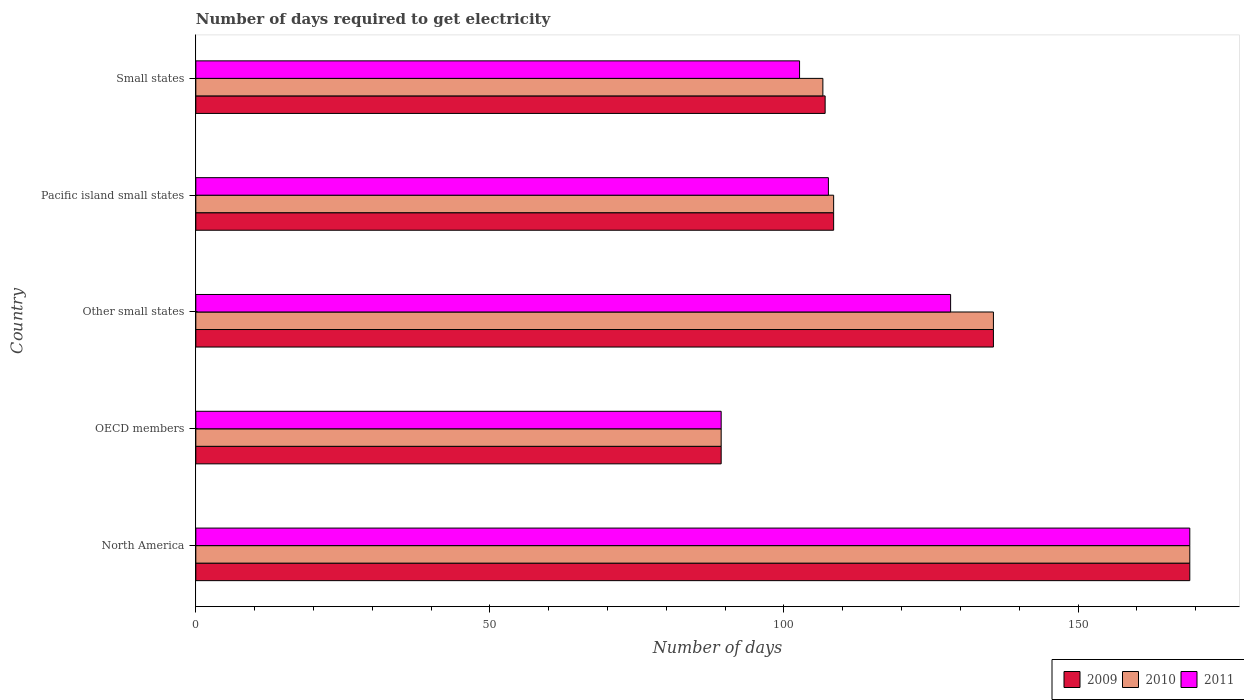How many groups of bars are there?
Your response must be concise. 5. Are the number of bars on each tick of the Y-axis equal?
Your response must be concise. Yes. How many bars are there on the 2nd tick from the bottom?
Your response must be concise. 3. What is the number of days required to get electricity in in 2011 in Small states?
Your answer should be very brief. 102.65. Across all countries, what is the maximum number of days required to get electricity in in 2011?
Offer a terse response. 169. Across all countries, what is the minimum number of days required to get electricity in in 2011?
Keep it short and to the point. 89.32. In which country was the number of days required to get electricity in in 2009 maximum?
Keep it short and to the point. North America. What is the total number of days required to get electricity in in 2011 in the graph?
Give a very brief answer. 596.86. What is the difference between the number of days required to get electricity in in 2011 in North America and that in Pacific island small states?
Offer a terse response. 61.44. What is the difference between the number of days required to get electricity in in 2011 in Other small states and the number of days required to get electricity in in 2010 in OECD members?
Provide a short and direct response. 39.01. What is the average number of days required to get electricity in in 2009 per country?
Ensure brevity in your answer.  121.88. What is the difference between the number of days required to get electricity in in 2010 and number of days required to get electricity in in 2009 in North America?
Offer a terse response. 0. In how many countries, is the number of days required to get electricity in in 2011 greater than 30 days?
Ensure brevity in your answer.  5. What is the ratio of the number of days required to get electricity in in 2011 in North America to that in Small states?
Offer a terse response. 1.65. Is the number of days required to get electricity in in 2010 in OECD members less than that in Small states?
Your answer should be compact. Yes. Is the difference between the number of days required to get electricity in in 2010 in North America and Pacific island small states greater than the difference between the number of days required to get electricity in in 2009 in North America and Pacific island small states?
Your answer should be very brief. No. What is the difference between the highest and the second highest number of days required to get electricity in in 2011?
Your answer should be compact. 40.67. What is the difference between the highest and the lowest number of days required to get electricity in in 2009?
Provide a short and direct response. 79.68. What does the 3rd bar from the top in North America represents?
Your answer should be very brief. 2009. Is it the case that in every country, the sum of the number of days required to get electricity in in 2010 and number of days required to get electricity in in 2009 is greater than the number of days required to get electricity in in 2011?
Your answer should be compact. Yes. How many bars are there?
Ensure brevity in your answer.  15. Does the graph contain grids?
Offer a very short reply. No. How are the legend labels stacked?
Offer a terse response. Horizontal. What is the title of the graph?
Give a very brief answer. Number of days required to get electricity. Does "2003" appear as one of the legend labels in the graph?
Provide a succinct answer. No. What is the label or title of the X-axis?
Offer a terse response. Number of days. What is the Number of days of 2009 in North America?
Provide a succinct answer. 169. What is the Number of days of 2010 in North America?
Provide a short and direct response. 169. What is the Number of days in 2011 in North America?
Keep it short and to the point. 169. What is the Number of days of 2009 in OECD members?
Provide a short and direct response. 89.32. What is the Number of days in 2010 in OECD members?
Your response must be concise. 89.32. What is the Number of days in 2011 in OECD members?
Your response must be concise. 89.32. What is the Number of days in 2009 in Other small states?
Offer a terse response. 135.61. What is the Number of days of 2010 in Other small states?
Your answer should be very brief. 135.61. What is the Number of days of 2011 in Other small states?
Ensure brevity in your answer.  128.33. What is the Number of days in 2009 in Pacific island small states?
Offer a terse response. 108.44. What is the Number of days of 2010 in Pacific island small states?
Give a very brief answer. 108.44. What is the Number of days in 2011 in Pacific island small states?
Your answer should be compact. 107.56. What is the Number of days of 2009 in Small states?
Offer a terse response. 107. What is the Number of days in 2010 in Small states?
Your answer should be compact. 106.62. What is the Number of days of 2011 in Small states?
Make the answer very short. 102.65. Across all countries, what is the maximum Number of days of 2009?
Your answer should be compact. 169. Across all countries, what is the maximum Number of days in 2010?
Provide a succinct answer. 169. Across all countries, what is the maximum Number of days of 2011?
Provide a short and direct response. 169. Across all countries, what is the minimum Number of days in 2009?
Your answer should be very brief. 89.32. Across all countries, what is the minimum Number of days in 2010?
Ensure brevity in your answer.  89.32. Across all countries, what is the minimum Number of days in 2011?
Offer a very short reply. 89.32. What is the total Number of days in 2009 in the graph?
Make the answer very short. 609.38. What is the total Number of days in 2010 in the graph?
Ensure brevity in your answer.  608.99. What is the total Number of days in 2011 in the graph?
Offer a very short reply. 596.86. What is the difference between the Number of days in 2009 in North America and that in OECD members?
Provide a succinct answer. 79.68. What is the difference between the Number of days of 2010 in North America and that in OECD members?
Provide a short and direct response. 79.68. What is the difference between the Number of days of 2011 in North America and that in OECD members?
Your response must be concise. 79.68. What is the difference between the Number of days in 2009 in North America and that in Other small states?
Give a very brief answer. 33.39. What is the difference between the Number of days of 2010 in North America and that in Other small states?
Ensure brevity in your answer.  33.39. What is the difference between the Number of days of 2011 in North America and that in Other small states?
Ensure brevity in your answer.  40.67. What is the difference between the Number of days of 2009 in North America and that in Pacific island small states?
Your answer should be very brief. 60.56. What is the difference between the Number of days in 2010 in North America and that in Pacific island small states?
Provide a short and direct response. 60.56. What is the difference between the Number of days of 2011 in North America and that in Pacific island small states?
Your answer should be compact. 61.44. What is the difference between the Number of days in 2009 in North America and that in Small states?
Your answer should be very brief. 62. What is the difference between the Number of days of 2010 in North America and that in Small states?
Provide a short and direct response. 62.38. What is the difference between the Number of days in 2011 in North America and that in Small states?
Provide a short and direct response. 66.35. What is the difference between the Number of days in 2009 in OECD members and that in Other small states?
Offer a very short reply. -46.29. What is the difference between the Number of days of 2010 in OECD members and that in Other small states?
Your answer should be compact. -46.29. What is the difference between the Number of days in 2011 in OECD members and that in Other small states?
Your answer should be very brief. -39.01. What is the difference between the Number of days of 2009 in OECD members and that in Pacific island small states?
Your answer should be compact. -19.12. What is the difference between the Number of days of 2010 in OECD members and that in Pacific island small states?
Make the answer very short. -19.12. What is the difference between the Number of days in 2011 in OECD members and that in Pacific island small states?
Provide a succinct answer. -18.23. What is the difference between the Number of days of 2009 in OECD members and that in Small states?
Offer a very short reply. -17.68. What is the difference between the Number of days in 2010 in OECD members and that in Small states?
Offer a very short reply. -17.29. What is the difference between the Number of days in 2011 in OECD members and that in Small states?
Your response must be concise. -13.33. What is the difference between the Number of days of 2009 in Other small states and that in Pacific island small states?
Ensure brevity in your answer.  27.17. What is the difference between the Number of days in 2010 in Other small states and that in Pacific island small states?
Offer a terse response. 27.17. What is the difference between the Number of days of 2011 in Other small states and that in Pacific island small states?
Give a very brief answer. 20.78. What is the difference between the Number of days of 2009 in Other small states and that in Small states?
Offer a very short reply. 28.61. What is the difference between the Number of days in 2010 in Other small states and that in Small states?
Provide a short and direct response. 29. What is the difference between the Number of days in 2011 in Other small states and that in Small states?
Your response must be concise. 25.68. What is the difference between the Number of days of 2009 in Pacific island small states and that in Small states?
Provide a succinct answer. 1.44. What is the difference between the Number of days of 2010 in Pacific island small states and that in Small states?
Provide a succinct answer. 1.83. What is the difference between the Number of days of 2011 in Pacific island small states and that in Small states?
Keep it short and to the point. 4.91. What is the difference between the Number of days of 2009 in North America and the Number of days of 2010 in OECD members?
Make the answer very short. 79.68. What is the difference between the Number of days of 2009 in North America and the Number of days of 2011 in OECD members?
Your response must be concise. 79.68. What is the difference between the Number of days in 2010 in North America and the Number of days in 2011 in OECD members?
Your answer should be very brief. 79.68. What is the difference between the Number of days in 2009 in North America and the Number of days in 2010 in Other small states?
Provide a short and direct response. 33.39. What is the difference between the Number of days of 2009 in North America and the Number of days of 2011 in Other small states?
Provide a succinct answer. 40.67. What is the difference between the Number of days of 2010 in North America and the Number of days of 2011 in Other small states?
Provide a short and direct response. 40.67. What is the difference between the Number of days of 2009 in North America and the Number of days of 2010 in Pacific island small states?
Offer a terse response. 60.56. What is the difference between the Number of days of 2009 in North America and the Number of days of 2011 in Pacific island small states?
Give a very brief answer. 61.44. What is the difference between the Number of days of 2010 in North America and the Number of days of 2011 in Pacific island small states?
Make the answer very short. 61.44. What is the difference between the Number of days in 2009 in North America and the Number of days in 2010 in Small states?
Offer a very short reply. 62.38. What is the difference between the Number of days in 2009 in North America and the Number of days in 2011 in Small states?
Offer a terse response. 66.35. What is the difference between the Number of days in 2010 in North America and the Number of days in 2011 in Small states?
Offer a terse response. 66.35. What is the difference between the Number of days of 2009 in OECD members and the Number of days of 2010 in Other small states?
Provide a short and direct response. -46.29. What is the difference between the Number of days in 2009 in OECD members and the Number of days in 2011 in Other small states?
Ensure brevity in your answer.  -39.01. What is the difference between the Number of days in 2010 in OECD members and the Number of days in 2011 in Other small states?
Make the answer very short. -39.01. What is the difference between the Number of days of 2009 in OECD members and the Number of days of 2010 in Pacific island small states?
Your answer should be very brief. -19.12. What is the difference between the Number of days of 2009 in OECD members and the Number of days of 2011 in Pacific island small states?
Offer a very short reply. -18.23. What is the difference between the Number of days of 2010 in OECD members and the Number of days of 2011 in Pacific island small states?
Provide a succinct answer. -18.23. What is the difference between the Number of days in 2009 in OECD members and the Number of days in 2010 in Small states?
Your answer should be compact. -17.29. What is the difference between the Number of days of 2009 in OECD members and the Number of days of 2011 in Small states?
Give a very brief answer. -13.33. What is the difference between the Number of days in 2010 in OECD members and the Number of days in 2011 in Small states?
Your answer should be compact. -13.33. What is the difference between the Number of days of 2009 in Other small states and the Number of days of 2010 in Pacific island small states?
Keep it short and to the point. 27.17. What is the difference between the Number of days in 2009 in Other small states and the Number of days in 2011 in Pacific island small states?
Provide a succinct answer. 28.06. What is the difference between the Number of days in 2010 in Other small states and the Number of days in 2011 in Pacific island small states?
Provide a short and direct response. 28.06. What is the difference between the Number of days in 2009 in Other small states and the Number of days in 2010 in Small states?
Provide a short and direct response. 29. What is the difference between the Number of days of 2009 in Other small states and the Number of days of 2011 in Small states?
Give a very brief answer. 32.96. What is the difference between the Number of days of 2010 in Other small states and the Number of days of 2011 in Small states?
Provide a succinct answer. 32.96. What is the difference between the Number of days of 2009 in Pacific island small states and the Number of days of 2010 in Small states?
Offer a terse response. 1.83. What is the difference between the Number of days in 2009 in Pacific island small states and the Number of days in 2011 in Small states?
Your answer should be compact. 5.79. What is the difference between the Number of days of 2010 in Pacific island small states and the Number of days of 2011 in Small states?
Make the answer very short. 5.79. What is the average Number of days in 2009 per country?
Offer a terse response. 121.88. What is the average Number of days in 2010 per country?
Give a very brief answer. 121.8. What is the average Number of days in 2011 per country?
Keep it short and to the point. 119.37. What is the difference between the Number of days in 2009 and Number of days in 2010 in North America?
Provide a short and direct response. 0. What is the difference between the Number of days of 2009 and Number of days of 2011 in North America?
Ensure brevity in your answer.  0. What is the difference between the Number of days of 2009 and Number of days of 2011 in OECD members?
Ensure brevity in your answer.  0. What is the difference between the Number of days of 2010 and Number of days of 2011 in OECD members?
Give a very brief answer. 0. What is the difference between the Number of days of 2009 and Number of days of 2010 in Other small states?
Give a very brief answer. 0. What is the difference between the Number of days in 2009 and Number of days in 2011 in Other small states?
Provide a short and direct response. 7.28. What is the difference between the Number of days in 2010 and Number of days in 2011 in Other small states?
Offer a very short reply. 7.28. What is the difference between the Number of days of 2009 and Number of days of 2011 in Pacific island small states?
Provide a short and direct response. 0.89. What is the difference between the Number of days of 2009 and Number of days of 2010 in Small states?
Provide a succinct answer. 0.38. What is the difference between the Number of days in 2009 and Number of days in 2011 in Small states?
Give a very brief answer. 4.35. What is the difference between the Number of days in 2010 and Number of days in 2011 in Small states?
Ensure brevity in your answer.  3.97. What is the ratio of the Number of days of 2009 in North America to that in OECD members?
Your answer should be compact. 1.89. What is the ratio of the Number of days of 2010 in North America to that in OECD members?
Your response must be concise. 1.89. What is the ratio of the Number of days of 2011 in North America to that in OECD members?
Your answer should be compact. 1.89. What is the ratio of the Number of days in 2009 in North America to that in Other small states?
Ensure brevity in your answer.  1.25. What is the ratio of the Number of days in 2010 in North America to that in Other small states?
Offer a terse response. 1.25. What is the ratio of the Number of days of 2011 in North America to that in Other small states?
Provide a short and direct response. 1.32. What is the ratio of the Number of days of 2009 in North America to that in Pacific island small states?
Your response must be concise. 1.56. What is the ratio of the Number of days in 2010 in North America to that in Pacific island small states?
Keep it short and to the point. 1.56. What is the ratio of the Number of days in 2011 in North America to that in Pacific island small states?
Your response must be concise. 1.57. What is the ratio of the Number of days of 2009 in North America to that in Small states?
Give a very brief answer. 1.58. What is the ratio of the Number of days in 2010 in North America to that in Small states?
Provide a succinct answer. 1.59. What is the ratio of the Number of days of 2011 in North America to that in Small states?
Your answer should be compact. 1.65. What is the ratio of the Number of days in 2009 in OECD members to that in Other small states?
Keep it short and to the point. 0.66. What is the ratio of the Number of days in 2010 in OECD members to that in Other small states?
Offer a terse response. 0.66. What is the ratio of the Number of days of 2011 in OECD members to that in Other small states?
Make the answer very short. 0.7. What is the ratio of the Number of days in 2009 in OECD members to that in Pacific island small states?
Ensure brevity in your answer.  0.82. What is the ratio of the Number of days of 2010 in OECD members to that in Pacific island small states?
Keep it short and to the point. 0.82. What is the ratio of the Number of days in 2011 in OECD members to that in Pacific island small states?
Give a very brief answer. 0.83. What is the ratio of the Number of days in 2009 in OECD members to that in Small states?
Your answer should be compact. 0.83. What is the ratio of the Number of days in 2010 in OECD members to that in Small states?
Offer a very short reply. 0.84. What is the ratio of the Number of days of 2011 in OECD members to that in Small states?
Keep it short and to the point. 0.87. What is the ratio of the Number of days in 2009 in Other small states to that in Pacific island small states?
Keep it short and to the point. 1.25. What is the ratio of the Number of days in 2010 in Other small states to that in Pacific island small states?
Your response must be concise. 1.25. What is the ratio of the Number of days in 2011 in Other small states to that in Pacific island small states?
Keep it short and to the point. 1.19. What is the ratio of the Number of days in 2009 in Other small states to that in Small states?
Provide a succinct answer. 1.27. What is the ratio of the Number of days in 2010 in Other small states to that in Small states?
Your answer should be very brief. 1.27. What is the ratio of the Number of days in 2011 in Other small states to that in Small states?
Make the answer very short. 1.25. What is the ratio of the Number of days in 2009 in Pacific island small states to that in Small states?
Make the answer very short. 1.01. What is the ratio of the Number of days in 2010 in Pacific island small states to that in Small states?
Make the answer very short. 1.02. What is the ratio of the Number of days in 2011 in Pacific island small states to that in Small states?
Offer a terse response. 1.05. What is the difference between the highest and the second highest Number of days of 2009?
Give a very brief answer. 33.39. What is the difference between the highest and the second highest Number of days in 2010?
Your response must be concise. 33.39. What is the difference between the highest and the second highest Number of days of 2011?
Provide a succinct answer. 40.67. What is the difference between the highest and the lowest Number of days in 2009?
Your answer should be very brief. 79.68. What is the difference between the highest and the lowest Number of days in 2010?
Make the answer very short. 79.68. What is the difference between the highest and the lowest Number of days of 2011?
Provide a short and direct response. 79.68. 